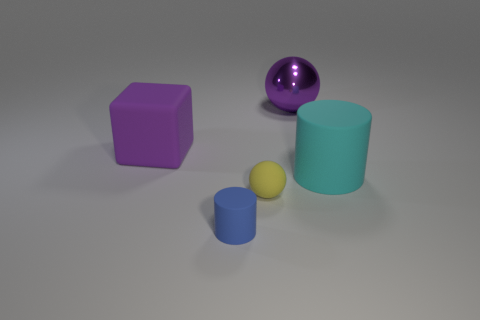Add 1 tiny balls. How many objects exist? 6 Subtract all blocks. How many objects are left? 4 Subtract 0 brown balls. How many objects are left? 5 Subtract all big green balls. Subtract all blue matte cylinders. How many objects are left? 4 Add 5 big cyan cylinders. How many big cyan cylinders are left? 6 Add 1 yellow matte blocks. How many yellow matte blocks exist? 1 